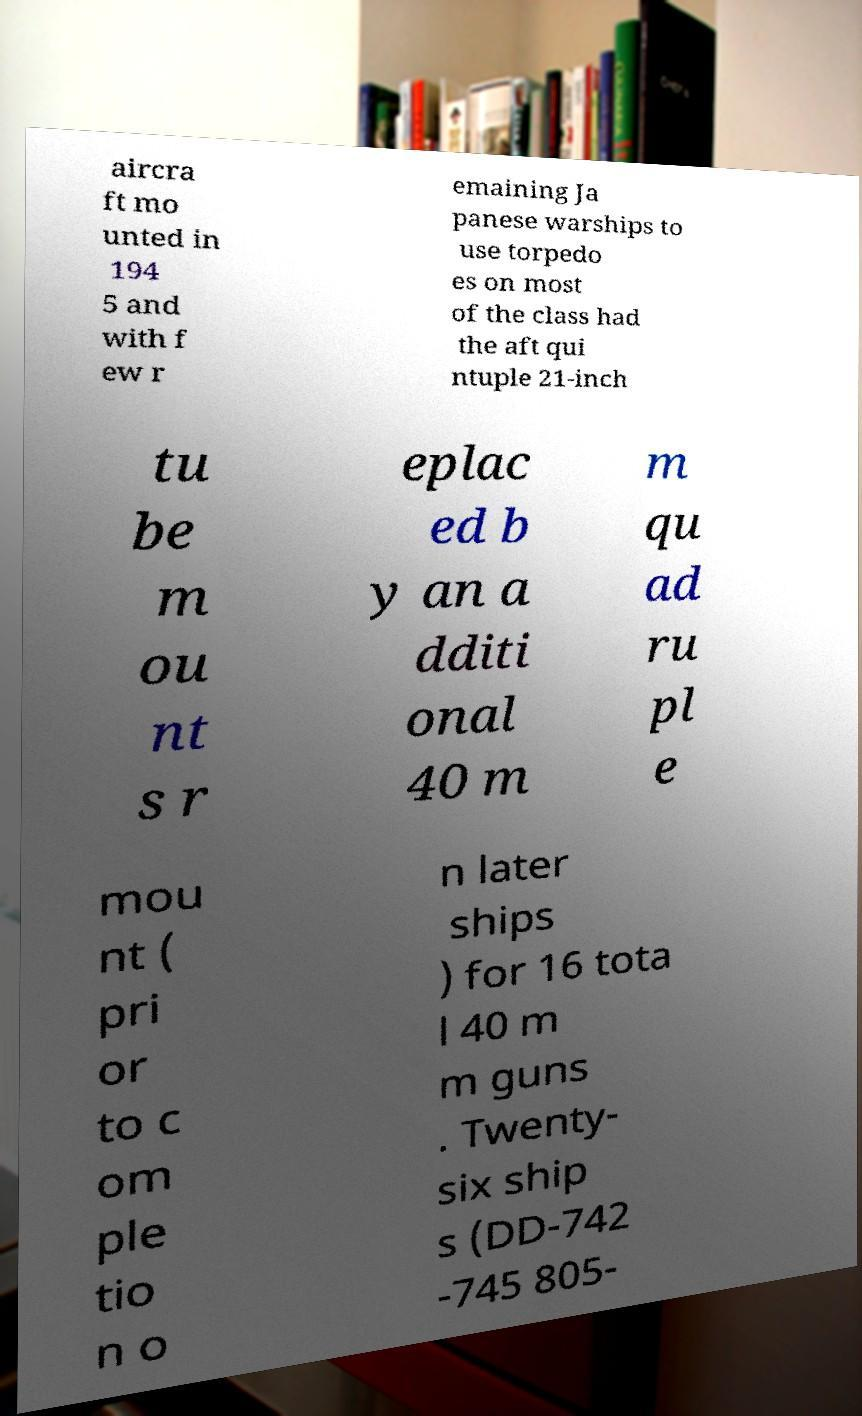For documentation purposes, I need the text within this image transcribed. Could you provide that? aircra ft mo unted in 194 5 and with f ew r emaining Ja panese warships to use torpedo es on most of the class had the aft qui ntuple 21-inch tu be m ou nt s r eplac ed b y an a dditi onal 40 m m qu ad ru pl e mou nt ( pri or to c om ple tio n o n later ships ) for 16 tota l 40 m m guns . Twenty- six ship s (DD-742 -745 805- 